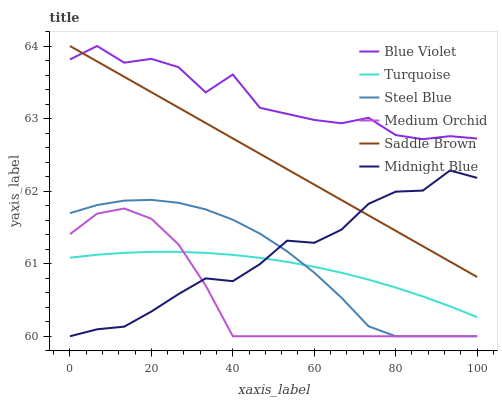Does Medium Orchid have the minimum area under the curve?
Answer yes or no. Yes. Does Blue Violet have the maximum area under the curve?
Answer yes or no. Yes. Does Midnight Blue have the minimum area under the curve?
Answer yes or no. No. Does Midnight Blue have the maximum area under the curve?
Answer yes or no. No. Is Saddle Brown the smoothest?
Answer yes or no. Yes. Is Blue Violet the roughest?
Answer yes or no. Yes. Is Midnight Blue the smoothest?
Answer yes or no. No. Is Midnight Blue the roughest?
Answer yes or no. No. Does Midnight Blue have the lowest value?
Answer yes or no. Yes. Does Saddle Brown have the lowest value?
Answer yes or no. No. Does Blue Violet have the highest value?
Answer yes or no. Yes. Does Midnight Blue have the highest value?
Answer yes or no. No. Is Midnight Blue less than Blue Violet?
Answer yes or no. Yes. Is Blue Violet greater than Medium Orchid?
Answer yes or no. Yes. Does Midnight Blue intersect Saddle Brown?
Answer yes or no. Yes. Is Midnight Blue less than Saddle Brown?
Answer yes or no. No. Is Midnight Blue greater than Saddle Brown?
Answer yes or no. No. Does Midnight Blue intersect Blue Violet?
Answer yes or no. No. 